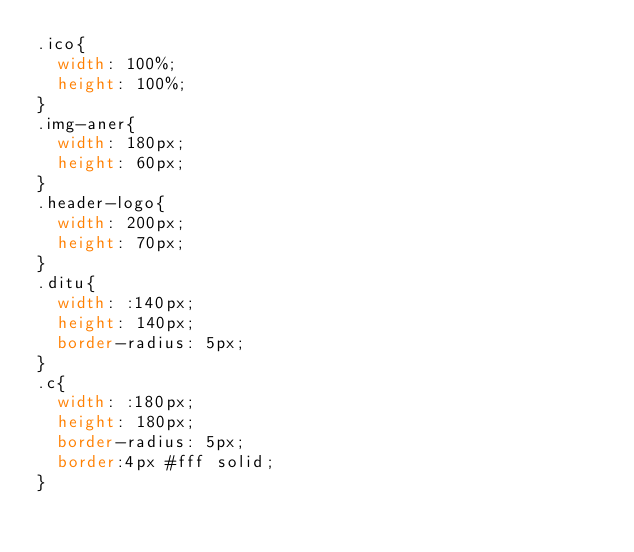Convert code to text. <code><loc_0><loc_0><loc_500><loc_500><_CSS_>.ico{
	width: 100%;
	height: 100%;
}
.img-aner{
	width: 180px;
	height: 60px;
}
.header-logo{
	width: 200px;
	height: 70px;
}
.ditu{
	width: :140px;
	height: 140px;
	border-radius: 5px;
}
.c{
	width: :180px;
	height: 180px;
	border-radius: 5px;
	border:4px #fff solid;
}</code> 